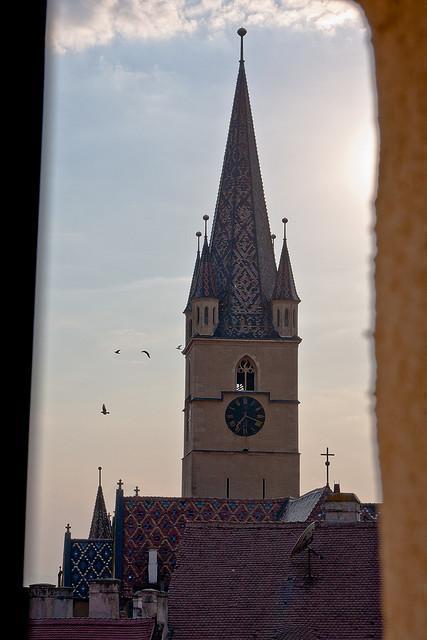How many towers are on the top of the clock tower with a black clock face?
Choose the correct response, then elucidate: 'Answer: answer
Rationale: rationale.'
Options: Four, two, three, five. Answer: five.
Rationale: There are five towers. 